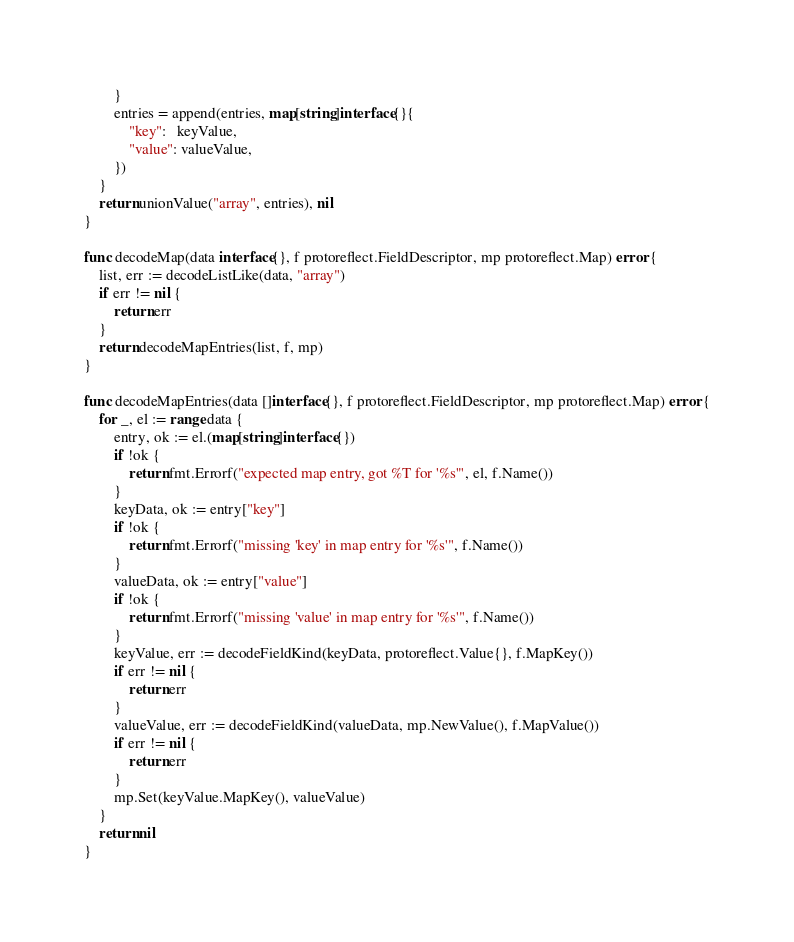<code> <loc_0><loc_0><loc_500><loc_500><_Go_>		}
		entries = append(entries, map[string]interface{}{
			"key":   keyValue,
			"value": valueValue,
		})
	}
	return unionValue("array", entries), nil
}

func decodeMap(data interface{}, f protoreflect.FieldDescriptor, mp protoreflect.Map) error {
	list, err := decodeListLike(data, "array")
	if err != nil {
		return err
	}
	return decodeMapEntries(list, f, mp)
}

func decodeMapEntries(data []interface{}, f protoreflect.FieldDescriptor, mp protoreflect.Map) error {
	for _, el := range data {
		entry, ok := el.(map[string]interface{})
		if !ok {
			return fmt.Errorf("expected map entry, got %T for '%s'", el, f.Name())
		}
		keyData, ok := entry["key"]
		if !ok {
			return fmt.Errorf("missing 'key' in map entry for '%s'", f.Name())
		}
		valueData, ok := entry["value"]
		if !ok {
			return fmt.Errorf("missing 'value' in map entry for '%s'", f.Name())
		}
		keyValue, err := decodeFieldKind(keyData, protoreflect.Value{}, f.MapKey())
		if err != nil {
			return err
		}
		valueValue, err := decodeFieldKind(valueData, mp.NewValue(), f.MapValue())
		if err != nil {
			return err
		}
		mp.Set(keyValue.MapKey(), valueValue)
	}
	return nil
}
</code> 